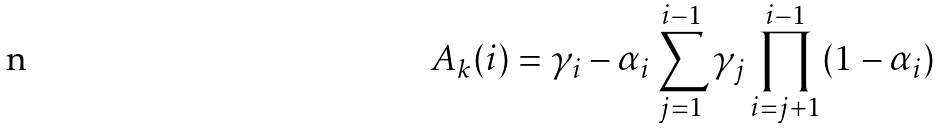<formula> <loc_0><loc_0><loc_500><loc_500>A _ { k } ( i ) = \gamma _ { i } - \alpha _ { i } \sum _ { j = 1 } ^ { i - 1 } \gamma _ { j } \prod _ { i = j + 1 } ^ { i - 1 } ( 1 - \alpha _ { i } )</formula> 